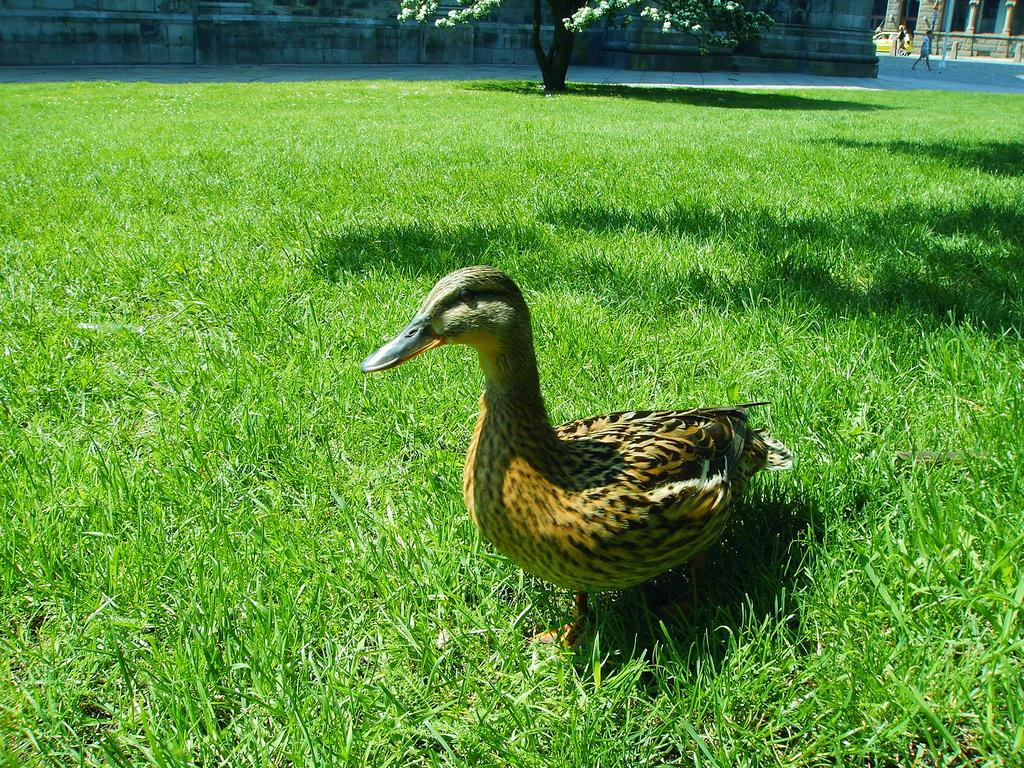What type of animal is on the grass in the image? There is a bird on the grass in the image. What can be seen in the background of the image? There are people, a pole, and a tree in the background of the image. What type of sense does the bird have in the image? The image does not provide information about the bird's senses, so it cannot be determined from the picture. Is there a minister present in the image? There is no mention of a minister in the image. What type of object is the bird sitting on in the image? The bird is on the grass in the image, not on a crate. 